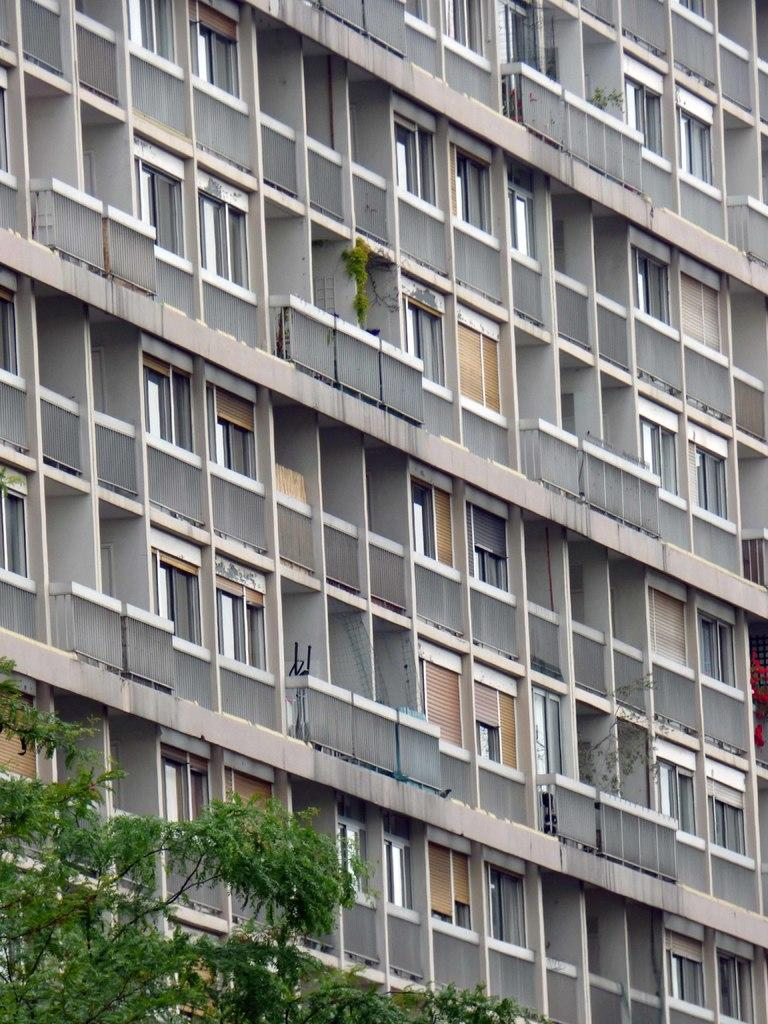What type of natural element is present in the image? There is a tree in the image. What type of man-made structure is present in the image? There is a building in the image. What type of dirt can be seen on the door of the building in the image? There is no dirt visible on the door of the building in the image, and there is no door mentioned in the provided facts. 